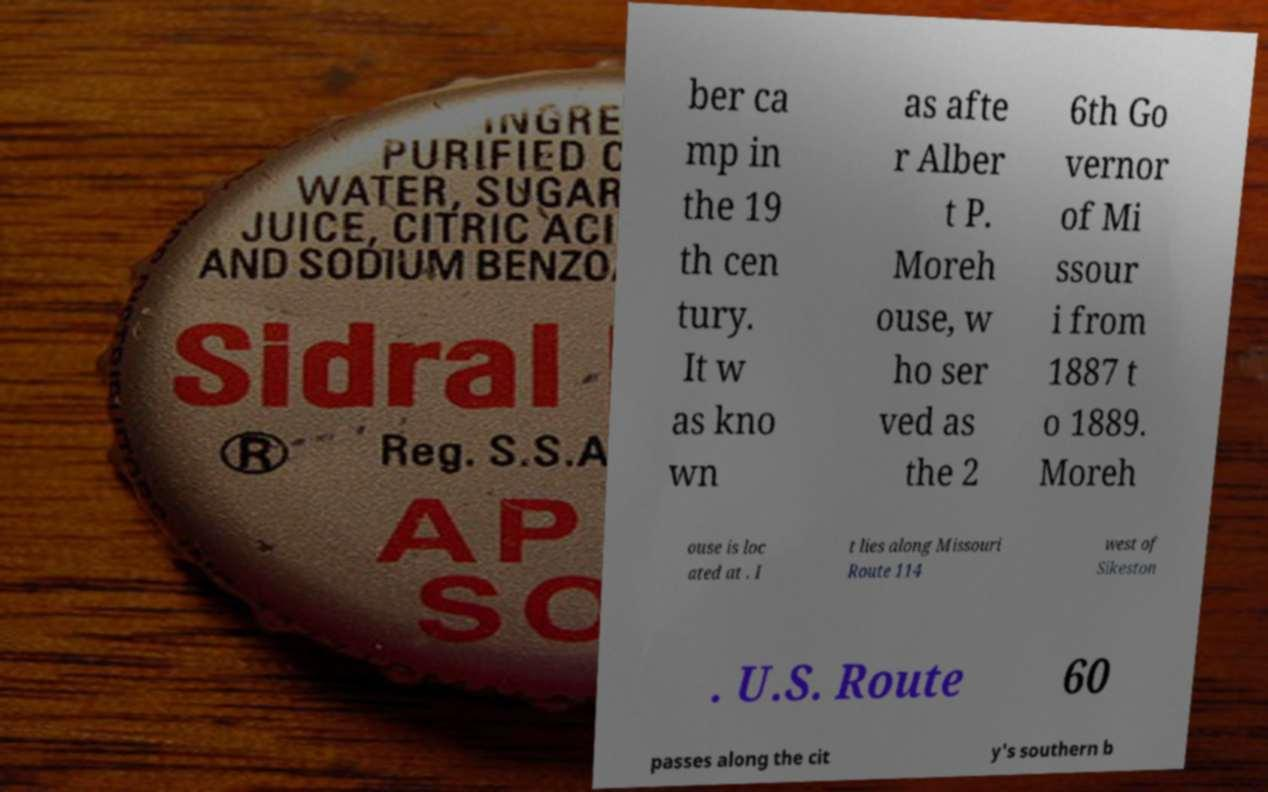For documentation purposes, I need the text within this image transcribed. Could you provide that? ber ca mp in the 19 th cen tury. It w as kno wn as afte r Alber t P. Moreh ouse, w ho ser ved as the 2 6th Go vernor of Mi ssour i from 1887 t o 1889. Moreh ouse is loc ated at . I t lies along Missouri Route 114 west of Sikeston . U.S. Route 60 passes along the cit y's southern b 